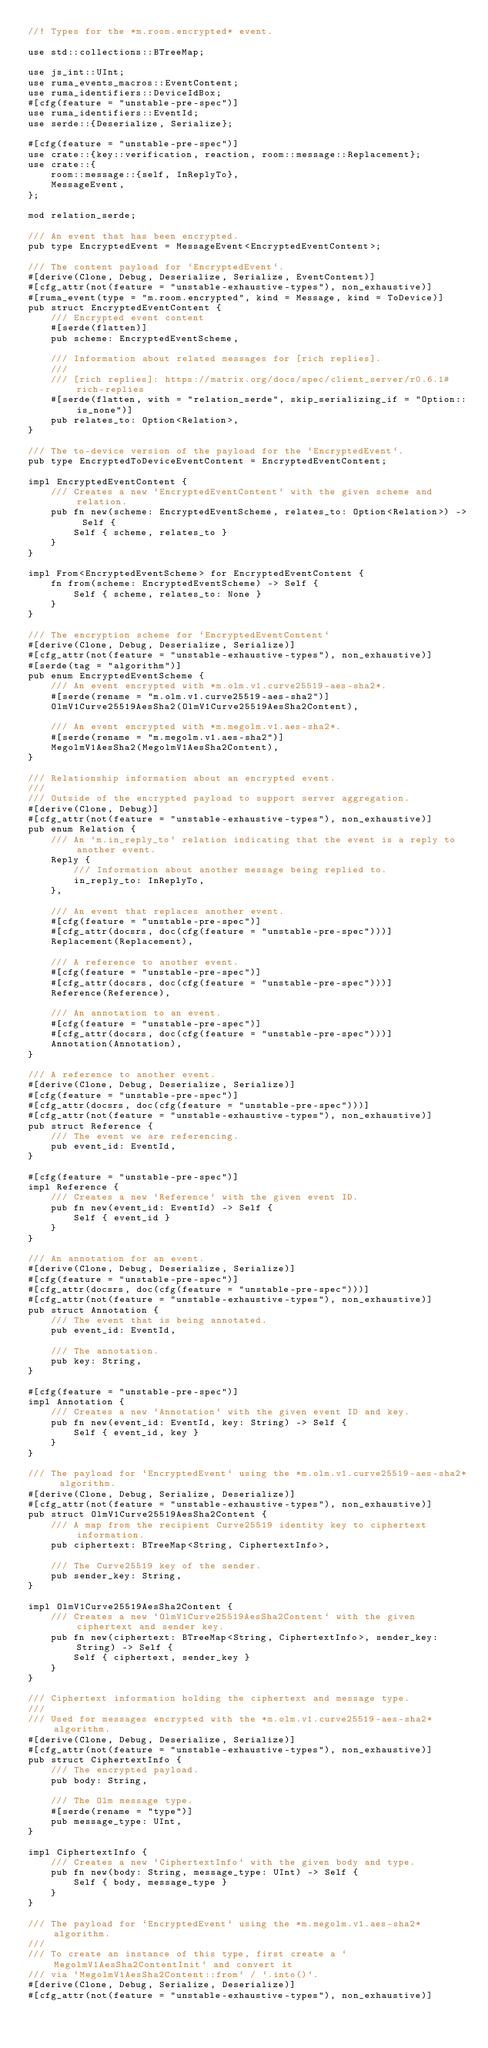Convert code to text. <code><loc_0><loc_0><loc_500><loc_500><_Rust_>//! Types for the *m.room.encrypted* event.

use std::collections::BTreeMap;

use js_int::UInt;
use ruma_events_macros::EventContent;
use ruma_identifiers::DeviceIdBox;
#[cfg(feature = "unstable-pre-spec")]
use ruma_identifiers::EventId;
use serde::{Deserialize, Serialize};

#[cfg(feature = "unstable-pre-spec")]
use crate::{key::verification, reaction, room::message::Replacement};
use crate::{
    room::message::{self, InReplyTo},
    MessageEvent,
};

mod relation_serde;

/// An event that has been encrypted.
pub type EncryptedEvent = MessageEvent<EncryptedEventContent>;

/// The content payload for `EncryptedEvent`.
#[derive(Clone, Debug, Deserialize, Serialize, EventContent)]
#[cfg_attr(not(feature = "unstable-exhaustive-types"), non_exhaustive)]
#[ruma_event(type = "m.room.encrypted", kind = Message, kind = ToDevice)]
pub struct EncryptedEventContent {
    /// Encrypted event content
    #[serde(flatten)]
    pub scheme: EncryptedEventScheme,

    /// Information about related messages for [rich replies].
    ///
    /// [rich replies]: https://matrix.org/docs/spec/client_server/r0.6.1#rich-replies
    #[serde(flatten, with = "relation_serde", skip_serializing_if = "Option::is_none")]
    pub relates_to: Option<Relation>,
}

/// The to-device version of the payload for the `EncryptedEvent`.
pub type EncryptedToDeviceEventContent = EncryptedEventContent;

impl EncryptedEventContent {
    /// Creates a new `EncryptedEventContent` with the given scheme and relation.
    pub fn new(scheme: EncryptedEventScheme, relates_to: Option<Relation>) -> Self {
        Self { scheme, relates_to }
    }
}

impl From<EncryptedEventScheme> for EncryptedEventContent {
    fn from(scheme: EncryptedEventScheme) -> Self {
        Self { scheme, relates_to: None }
    }
}

/// The encryption scheme for `EncryptedEventContent`
#[derive(Clone, Debug, Deserialize, Serialize)]
#[cfg_attr(not(feature = "unstable-exhaustive-types"), non_exhaustive)]
#[serde(tag = "algorithm")]
pub enum EncryptedEventScheme {
    /// An event encrypted with *m.olm.v1.curve25519-aes-sha2*.
    #[serde(rename = "m.olm.v1.curve25519-aes-sha2")]
    OlmV1Curve25519AesSha2(OlmV1Curve25519AesSha2Content),

    /// An event encrypted with *m.megolm.v1.aes-sha2*.
    #[serde(rename = "m.megolm.v1.aes-sha2")]
    MegolmV1AesSha2(MegolmV1AesSha2Content),
}

/// Relationship information about an encrypted event.
///
/// Outside of the encrypted payload to support server aggregation.
#[derive(Clone, Debug)]
#[cfg_attr(not(feature = "unstable-exhaustive-types"), non_exhaustive)]
pub enum Relation {
    /// An `m.in_reply_to` relation indicating that the event is a reply to another event.
    Reply {
        /// Information about another message being replied to.
        in_reply_to: InReplyTo,
    },

    /// An event that replaces another event.
    #[cfg(feature = "unstable-pre-spec")]
    #[cfg_attr(docsrs, doc(cfg(feature = "unstable-pre-spec")))]
    Replacement(Replacement),

    /// A reference to another event.
    #[cfg(feature = "unstable-pre-spec")]
    #[cfg_attr(docsrs, doc(cfg(feature = "unstable-pre-spec")))]
    Reference(Reference),

    /// An annotation to an event.
    #[cfg(feature = "unstable-pre-spec")]
    #[cfg_attr(docsrs, doc(cfg(feature = "unstable-pre-spec")))]
    Annotation(Annotation),
}

/// A reference to another event.
#[derive(Clone, Debug, Deserialize, Serialize)]
#[cfg(feature = "unstable-pre-spec")]
#[cfg_attr(docsrs, doc(cfg(feature = "unstable-pre-spec")))]
#[cfg_attr(not(feature = "unstable-exhaustive-types"), non_exhaustive)]
pub struct Reference {
    /// The event we are referencing.
    pub event_id: EventId,
}

#[cfg(feature = "unstable-pre-spec")]
impl Reference {
    /// Creates a new `Reference` with the given event ID.
    pub fn new(event_id: EventId) -> Self {
        Self { event_id }
    }
}

/// An annotation for an event.
#[derive(Clone, Debug, Deserialize, Serialize)]
#[cfg(feature = "unstable-pre-spec")]
#[cfg_attr(docsrs, doc(cfg(feature = "unstable-pre-spec")))]
#[cfg_attr(not(feature = "unstable-exhaustive-types"), non_exhaustive)]
pub struct Annotation {
    /// The event that is being annotated.
    pub event_id: EventId,

    /// The annotation.
    pub key: String,
}

#[cfg(feature = "unstable-pre-spec")]
impl Annotation {
    /// Creates a new `Annotation` with the given event ID and key.
    pub fn new(event_id: EventId, key: String) -> Self {
        Self { event_id, key }
    }
}

/// The payload for `EncryptedEvent` using the *m.olm.v1.curve25519-aes-sha2* algorithm.
#[derive(Clone, Debug, Serialize, Deserialize)]
#[cfg_attr(not(feature = "unstable-exhaustive-types"), non_exhaustive)]
pub struct OlmV1Curve25519AesSha2Content {
    /// A map from the recipient Curve25519 identity key to ciphertext information.
    pub ciphertext: BTreeMap<String, CiphertextInfo>,

    /// The Curve25519 key of the sender.
    pub sender_key: String,
}

impl OlmV1Curve25519AesSha2Content {
    /// Creates a new `OlmV1Curve25519AesSha2Content` with the given ciphertext and sender key.
    pub fn new(ciphertext: BTreeMap<String, CiphertextInfo>, sender_key: String) -> Self {
        Self { ciphertext, sender_key }
    }
}

/// Ciphertext information holding the ciphertext and message type.
///
/// Used for messages encrypted with the *m.olm.v1.curve25519-aes-sha2* algorithm.
#[derive(Clone, Debug, Deserialize, Serialize)]
#[cfg_attr(not(feature = "unstable-exhaustive-types"), non_exhaustive)]
pub struct CiphertextInfo {
    /// The encrypted payload.
    pub body: String,

    /// The Olm message type.
    #[serde(rename = "type")]
    pub message_type: UInt,
}

impl CiphertextInfo {
    /// Creates a new `CiphertextInfo` with the given body and type.
    pub fn new(body: String, message_type: UInt) -> Self {
        Self { body, message_type }
    }
}

/// The payload for `EncryptedEvent` using the *m.megolm.v1.aes-sha2* algorithm.
///
/// To create an instance of this type, first create a `MegolmV1AesSha2ContentInit` and convert it
/// via `MegolmV1AesSha2Content::from` / `.into()`.
#[derive(Clone, Debug, Serialize, Deserialize)]
#[cfg_attr(not(feature = "unstable-exhaustive-types"), non_exhaustive)]</code> 